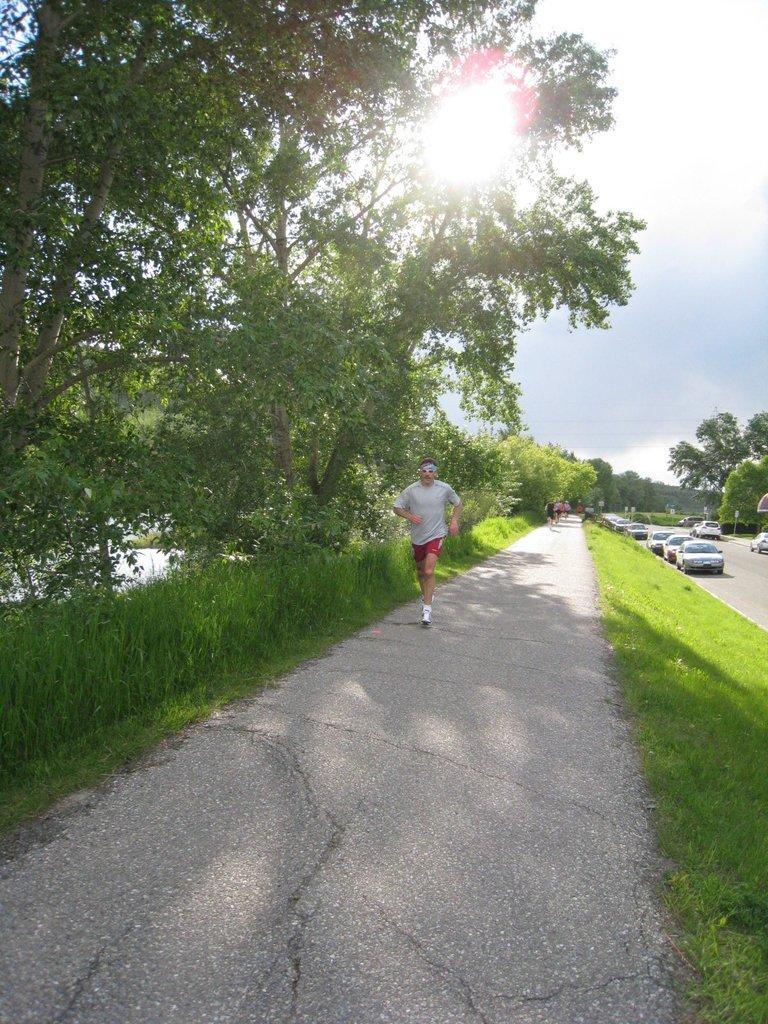In one or two sentences, can you explain what this image depicts? In the foreground of this image, there is a man running on the road. On either side there is grass. On the left, there are trees. On the right, there are vehicles moving on the road. At the top, there is sun and the sky. 